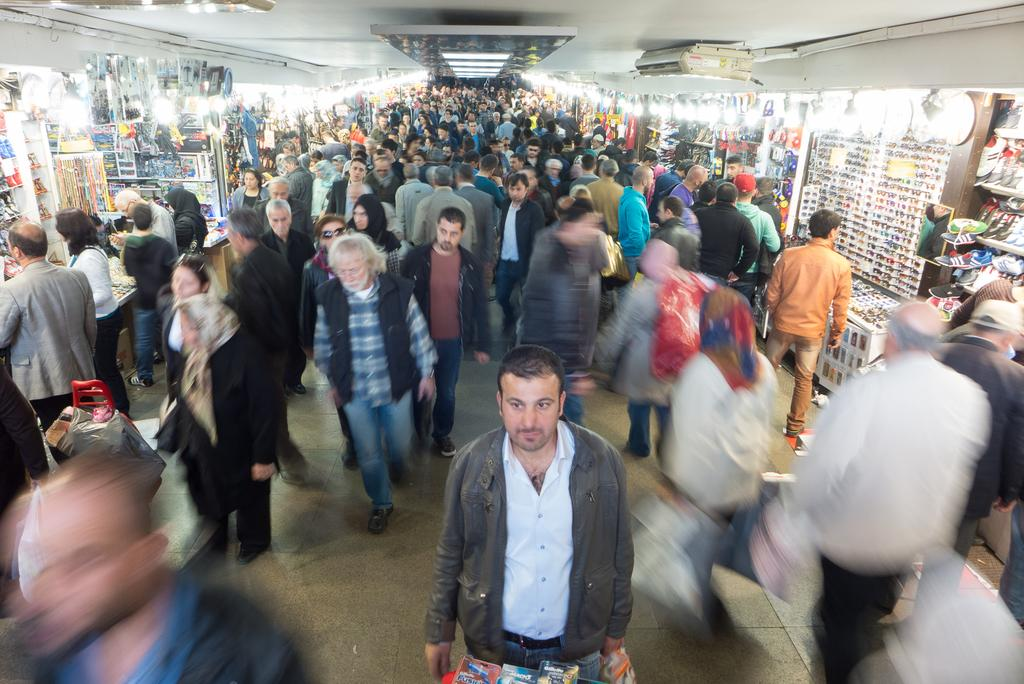What are the people in the image doing? The people in the image are standing and walking. What type of establishments can be seen in the image? There are stores in the image. What is above the people and stores in the image? There is a ceiling visible in the image. What helps to illuminate the area in the image? There are lights present in the image. What type of stamp can be seen on the beef in the image? There is no beef or stamp present in the image. 